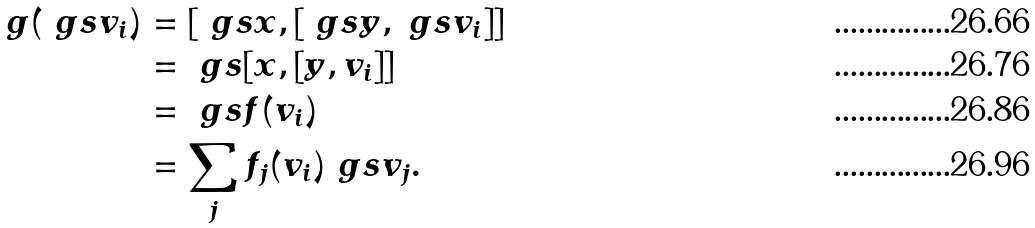Convert formula to latex. <formula><loc_0><loc_0><loc_500><loc_500>g ( \ g s v _ { i } ) & = [ \ g s x , [ \ g s y , \ g s v _ { i } ] ] \\ & = \ g s [ x , [ y , v _ { i } ] ] \\ & = \ g s f ( v _ { i } ) \\ & = \sum _ { j } f _ { j } ( v _ { i } ) \ g s v _ { j } .</formula> 